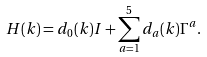<formula> <loc_0><loc_0><loc_500><loc_500>H ( { k } ) = d _ { 0 } ( { k } ) I + \sum _ { a = 1 } ^ { 5 } d _ { a } ( { k } ) \Gamma ^ { a } .</formula> 